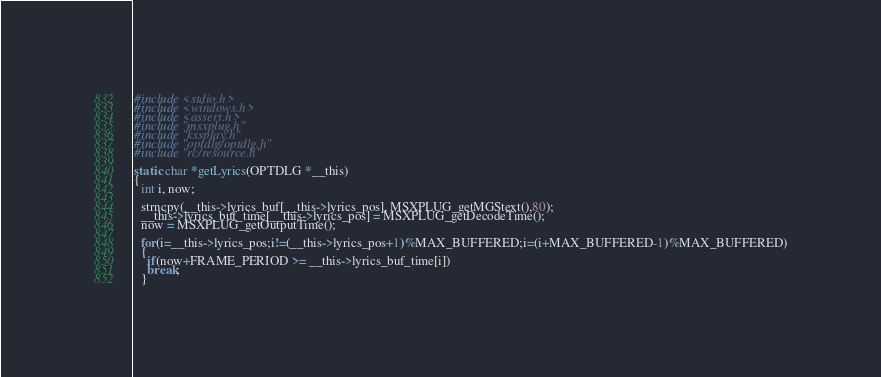Convert code to text. <code><loc_0><loc_0><loc_500><loc_500><_C_>#include <stdio.h>
#include <windows.h>
#include <assert.h>
#include "msxplug.h"
#include "kssplay.h"
#include "optdlg/optdlg.h"
#include "rc/resource.h"

static char *getLyrics(OPTDLG *__this)
{
  int i, now;

  strncpy(__this->lyrics_buf[__this->lyrics_pos], MSXPLUG_getMGStext(),80);
  __this->lyrics_buf_time[__this->lyrics_pos] = MSXPLUG_getDecodeTime();
  now = MSXPLUG_getOutputTime();

  for(i=__this->lyrics_pos;i!=(__this->lyrics_pos+1)%MAX_BUFFERED;i=(i+MAX_BUFFERED-1)%MAX_BUFFERED)
  {
    if(now+FRAME_PERIOD >= __this->lyrics_buf_time[i])
    break;
  }
</code> 